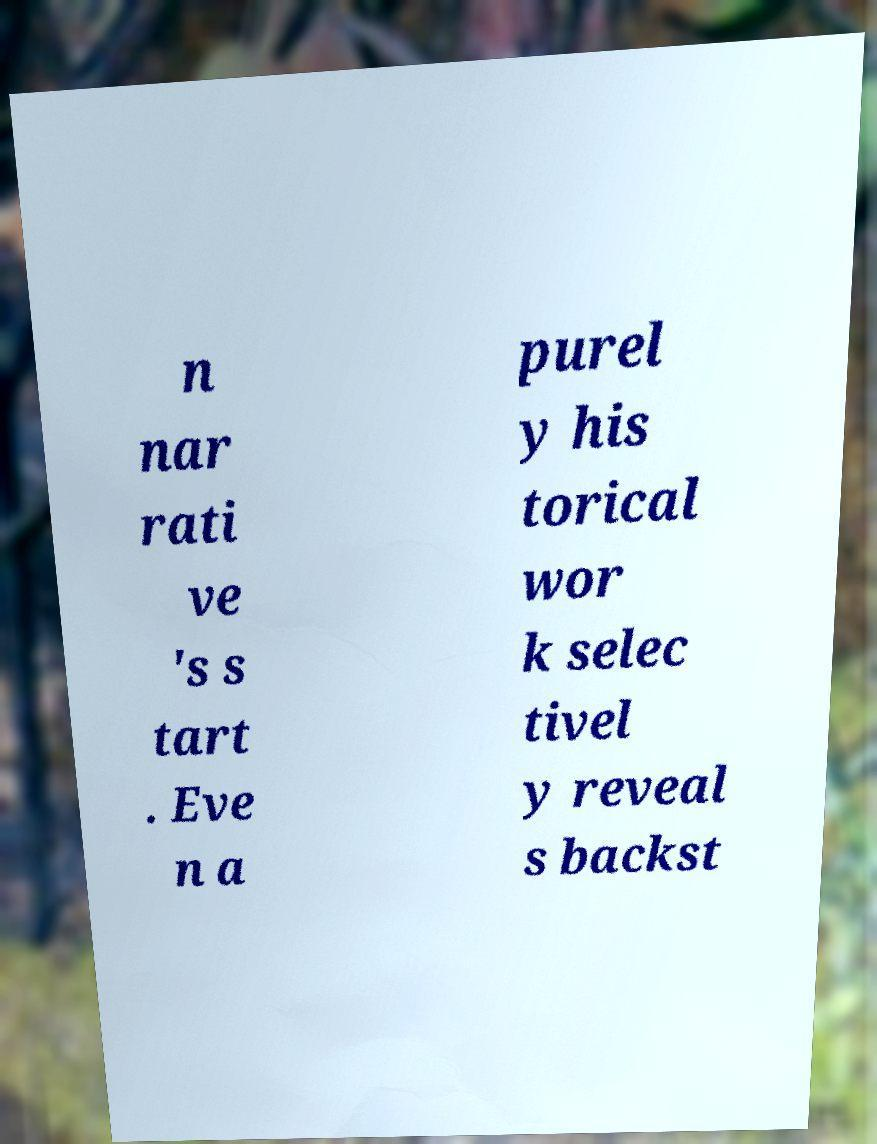Could you assist in decoding the text presented in this image and type it out clearly? n nar rati ve 's s tart . Eve n a purel y his torical wor k selec tivel y reveal s backst 